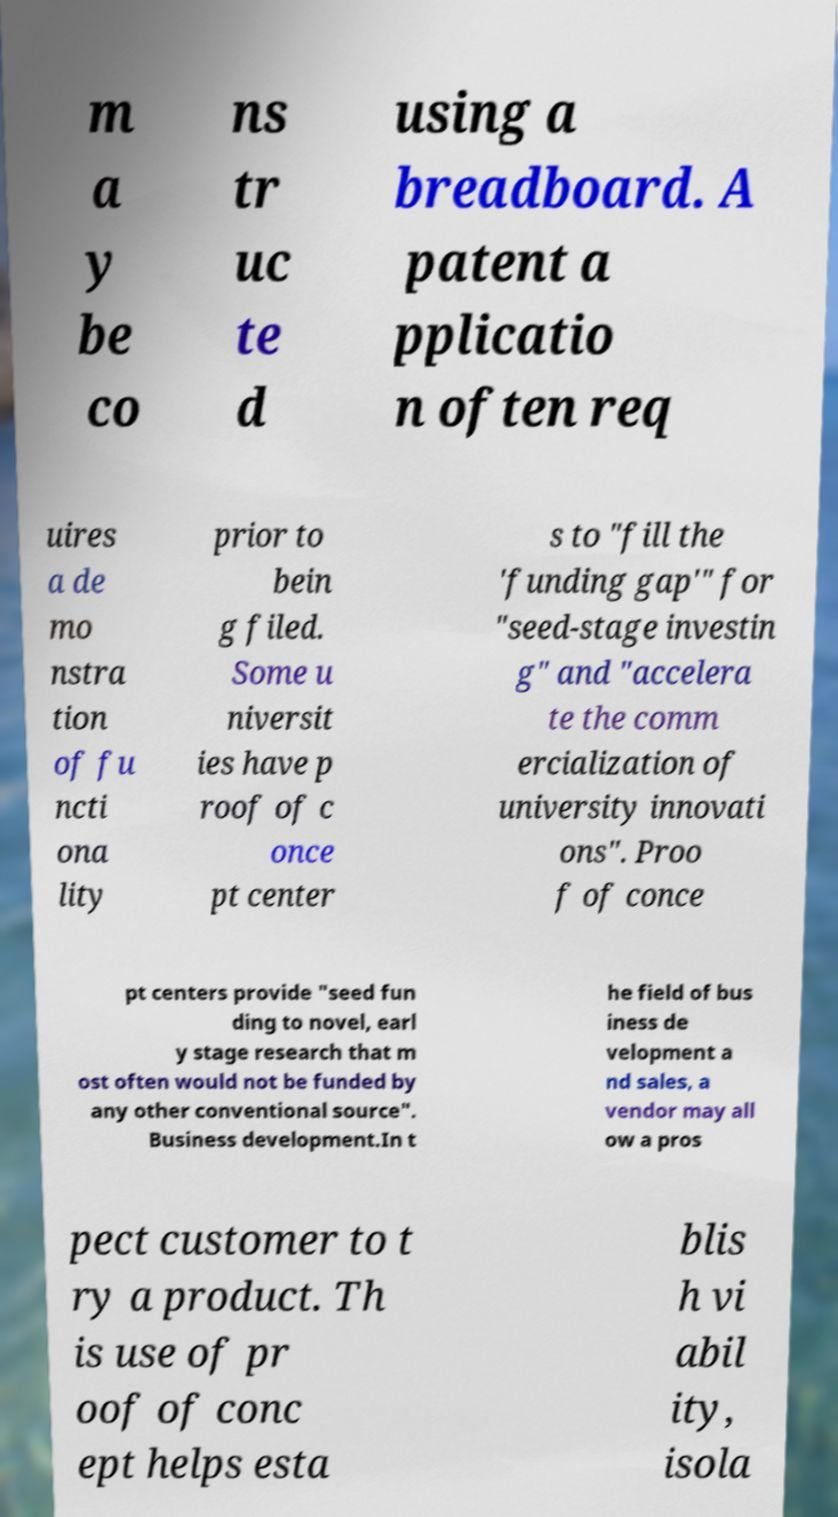Please read and relay the text visible in this image. What does it say? m a y be co ns tr uc te d using a breadboard. A patent a pplicatio n often req uires a de mo nstra tion of fu ncti ona lity prior to bein g filed. Some u niversit ies have p roof of c once pt center s to "fill the 'funding gap'" for "seed-stage investin g" and "accelera te the comm ercialization of university innovati ons". Proo f of conce pt centers provide "seed fun ding to novel, earl y stage research that m ost often would not be funded by any other conventional source". Business development.In t he field of bus iness de velopment a nd sales, a vendor may all ow a pros pect customer to t ry a product. Th is use of pr oof of conc ept helps esta blis h vi abil ity, isola 